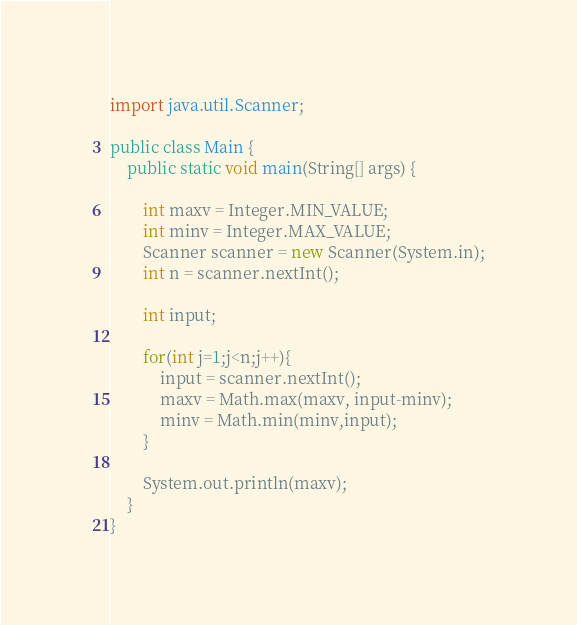<code> <loc_0><loc_0><loc_500><loc_500><_Java_>import java.util.Scanner;

public class Main {
	public static void main(String[] args) {

		int maxv = Integer.MIN_VALUE;
		int minv = Integer.MAX_VALUE;
		Scanner scanner = new Scanner(System.in);
		int n = scanner.nextInt();

		int input;
		
		for(int j=1;j<n;j++){
			input = scanner.nextInt();
			maxv = Math.max(maxv, input-minv);
			minv = Math.min(minv,input);
		}
		
		System.out.println(maxv);
	}
}</code> 